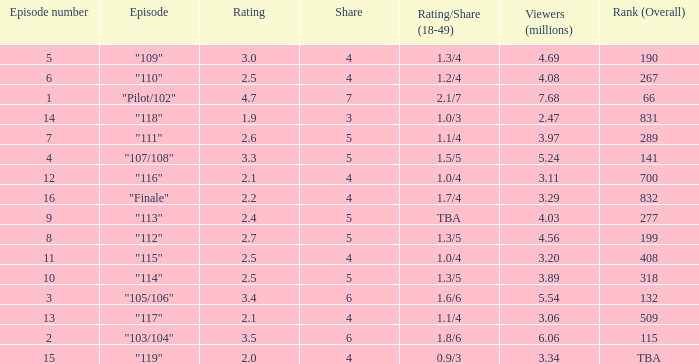WHAT IS THE HIGHEST VIEWERS WITH AN EPISODE LESS THAN 15 AND SHARE LAGER THAN 7? None. 